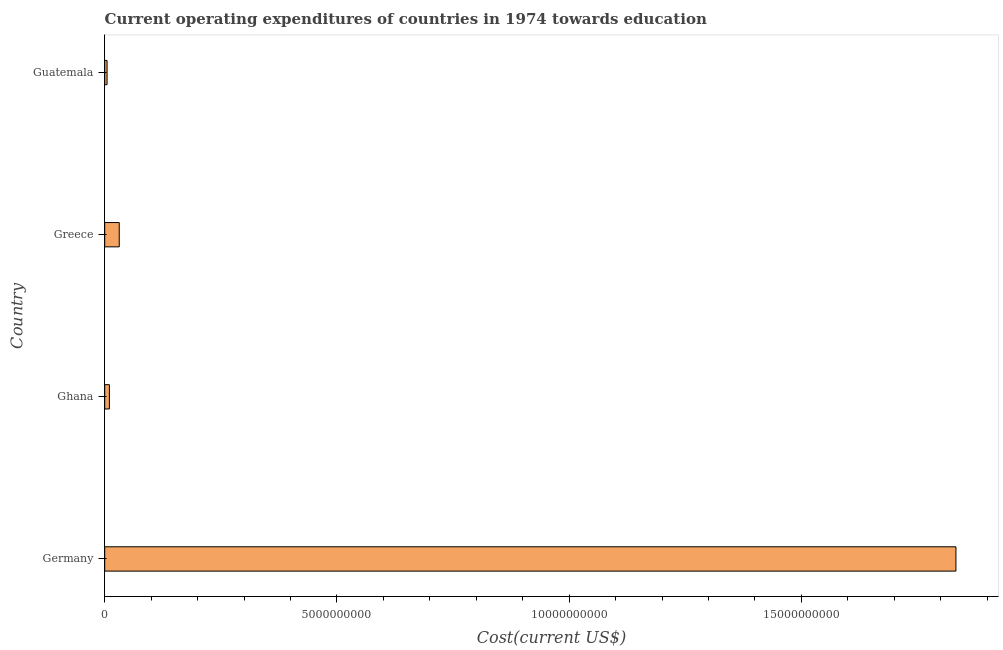Does the graph contain grids?
Your answer should be compact. No. What is the title of the graph?
Your response must be concise. Current operating expenditures of countries in 1974 towards education. What is the label or title of the X-axis?
Keep it short and to the point. Cost(current US$). What is the label or title of the Y-axis?
Offer a very short reply. Country. What is the education expenditure in Guatemala?
Offer a very short reply. 5.04e+07. Across all countries, what is the maximum education expenditure?
Ensure brevity in your answer.  1.83e+1. Across all countries, what is the minimum education expenditure?
Offer a very short reply. 5.04e+07. In which country was the education expenditure minimum?
Offer a very short reply. Guatemala. What is the sum of the education expenditure?
Keep it short and to the point. 1.88e+1. What is the difference between the education expenditure in Greece and Guatemala?
Keep it short and to the point. 2.62e+08. What is the average education expenditure per country?
Provide a short and direct response. 4.70e+09. What is the median education expenditure?
Your answer should be very brief. 2.07e+08. What is the ratio of the education expenditure in Germany to that in Greece?
Make the answer very short. 58.61. Is the education expenditure in Germany less than that in Ghana?
Provide a short and direct response. No. Is the difference between the education expenditure in Germany and Guatemala greater than the difference between any two countries?
Offer a terse response. Yes. What is the difference between the highest and the second highest education expenditure?
Make the answer very short. 1.80e+1. Is the sum of the education expenditure in Greece and Guatemala greater than the maximum education expenditure across all countries?
Ensure brevity in your answer.  No. What is the difference between the highest and the lowest education expenditure?
Give a very brief answer. 1.83e+1. In how many countries, is the education expenditure greater than the average education expenditure taken over all countries?
Ensure brevity in your answer.  1. Are all the bars in the graph horizontal?
Offer a very short reply. Yes. Are the values on the major ticks of X-axis written in scientific E-notation?
Provide a short and direct response. No. What is the Cost(current US$) of Germany?
Provide a succinct answer. 1.83e+1. What is the Cost(current US$) in Ghana?
Your answer should be compact. 1.01e+08. What is the Cost(current US$) of Greece?
Your answer should be very brief. 3.13e+08. What is the Cost(current US$) of Guatemala?
Offer a terse response. 5.04e+07. What is the difference between the Cost(current US$) in Germany and Ghana?
Offer a terse response. 1.82e+1. What is the difference between the Cost(current US$) in Germany and Greece?
Offer a terse response. 1.80e+1. What is the difference between the Cost(current US$) in Germany and Guatemala?
Give a very brief answer. 1.83e+1. What is the difference between the Cost(current US$) in Ghana and Greece?
Keep it short and to the point. -2.12e+08. What is the difference between the Cost(current US$) in Ghana and Guatemala?
Ensure brevity in your answer.  5.02e+07. What is the difference between the Cost(current US$) in Greece and Guatemala?
Ensure brevity in your answer.  2.62e+08. What is the ratio of the Cost(current US$) in Germany to that in Ghana?
Give a very brief answer. 182.13. What is the ratio of the Cost(current US$) in Germany to that in Greece?
Keep it short and to the point. 58.61. What is the ratio of the Cost(current US$) in Germany to that in Guatemala?
Offer a very short reply. 363.36. What is the ratio of the Cost(current US$) in Ghana to that in Greece?
Your answer should be very brief. 0.32. What is the ratio of the Cost(current US$) in Ghana to that in Guatemala?
Keep it short and to the point. 2. What is the ratio of the Cost(current US$) in Greece to that in Guatemala?
Offer a terse response. 6.2. 